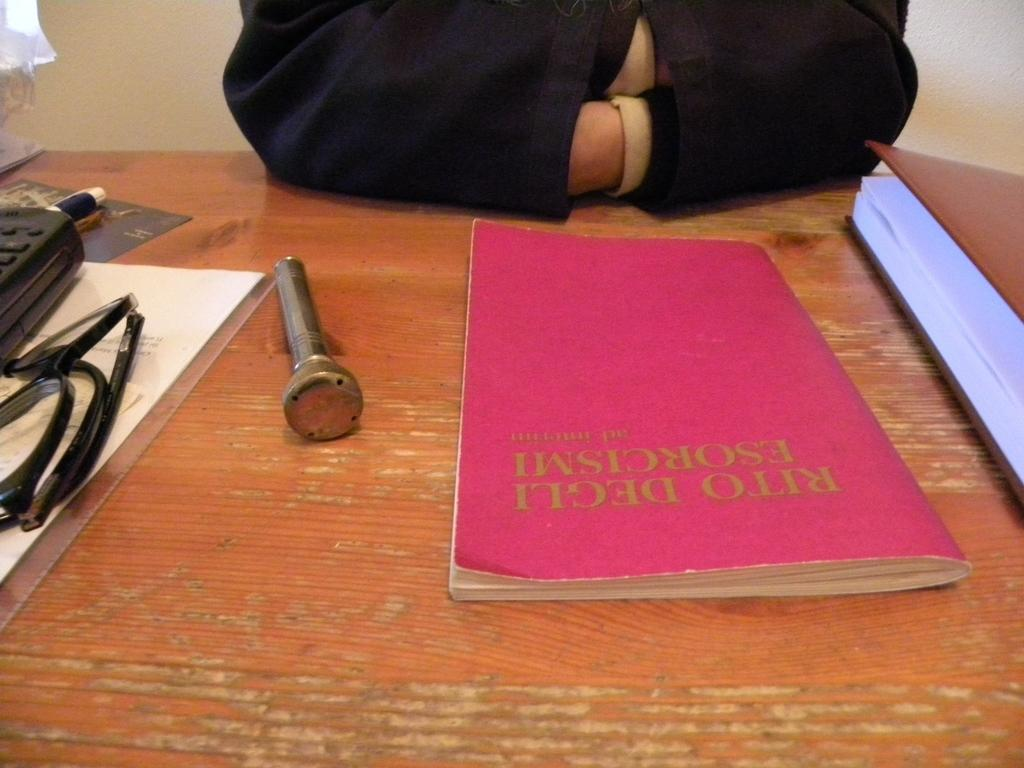Provide a one-sentence caption for the provided image. A man sits in front of a book titled Rito Degli: Esorcismi. 